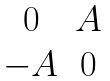<formula> <loc_0><loc_0><loc_500><loc_500>\begin{matrix} 0 & A \\ - A & 0 \end{matrix}</formula> 